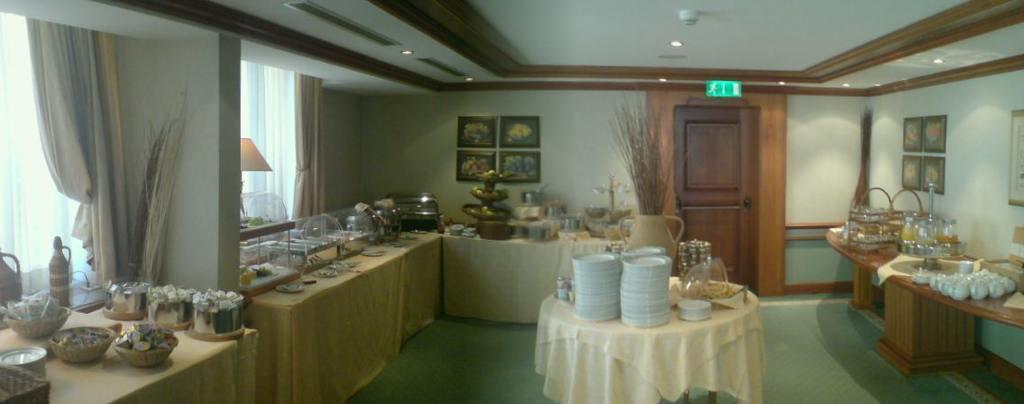Please provide a concise description of this image. This picture is an inside view of a kitchen. In this picture we can see the tables. On the tables we can see the cloths, plates, vessels, containers, food items, bottle, cup, stands and some other objects. In the background of the image we can see the wall, boards, lamp, curtains, windows, door, sign board. At the top of the image we can see the roof and lights. At the bottom of the image we can see the floor. 